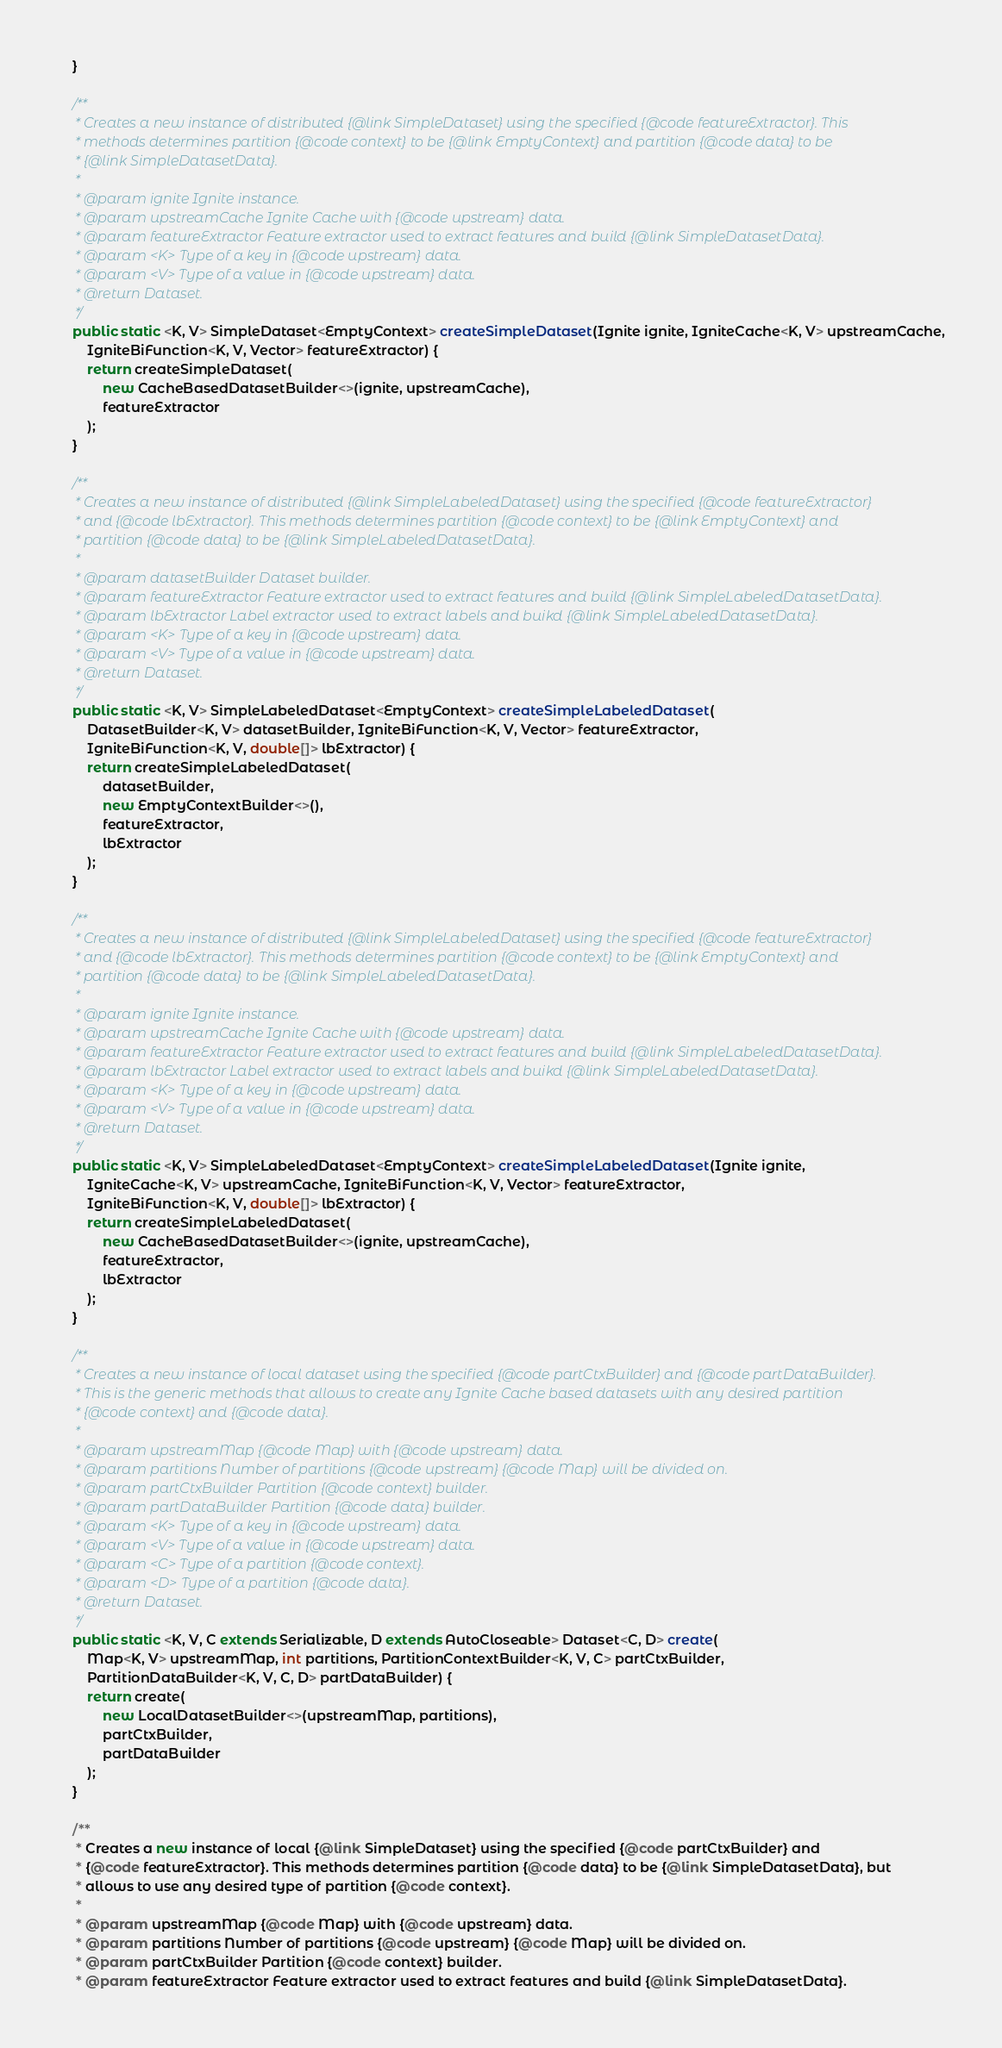<code> <loc_0><loc_0><loc_500><loc_500><_Java_>    }

    /**
     * Creates a new instance of distributed {@link SimpleDataset} using the specified {@code featureExtractor}. This
     * methods determines partition {@code context} to be {@link EmptyContext} and partition {@code data} to be
     * {@link SimpleDatasetData}.
     *
     * @param ignite Ignite instance.
     * @param upstreamCache Ignite Cache with {@code upstream} data.
     * @param featureExtractor Feature extractor used to extract features and build {@link SimpleDatasetData}.
     * @param <K> Type of a key in {@code upstream} data.
     * @param <V> Type of a value in {@code upstream} data.
     * @return Dataset.
     */
    public static <K, V> SimpleDataset<EmptyContext> createSimpleDataset(Ignite ignite, IgniteCache<K, V> upstreamCache,
        IgniteBiFunction<K, V, Vector> featureExtractor) {
        return createSimpleDataset(
            new CacheBasedDatasetBuilder<>(ignite, upstreamCache),
            featureExtractor
        );
    }

    /**
     * Creates a new instance of distributed {@link SimpleLabeledDataset} using the specified {@code featureExtractor}
     * and {@code lbExtractor}. This methods determines partition {@code context} to be {@link EmptyContext} and
     * partition {@code data} to be {@link SimpleLabeledDatasetData}.
     *
     * @param datasetBuilder Dataset builder.
     * @param featureExtractor Feature extractor used to extract features and build {@link SimpleLabeledDatasetData}.
     * @param lbExtractor Label extractor used to extract labels and buikd {@link SimpleLabeledDatasetData}.
     * @param <K> Type of a key in {@code upstream} data.
     * @param <V> Type of a value in {@code upstream} data.
     * @return Dataset.
     */
    public static <K, V> SimpleLabeledDataset<EmptyContext> createSimpleLabeledDataset(
        DatasetBuilder<K, V> datasetBuilder, IgniteBiFunction<K, V, Vector> featureExtractor,
        IgniteBiFunction<K, V, double[]> lbExtractor) {
        return createSimpleLabeledDataset(
            datasetBuilder,
            new EmptyContextBuilder<>(),
            featureExtractor,
            lbExtractor
        );
    }

    /**
     * Creates a new instance of distributed {@link SimpleLabeledDataset} using the specified {@code featureExtractor}
     * and {@code lbExtractor}. This methods determines partition {@code context} to be {@link EmptyContext} and
     * partition {@code data} to be {@link SimpleLabeledDatasetData}.
     *
     * @param ignite Ignite instance.
     * @param upstreamCache Ignite Cache with {@code upstream} data.
     * @param featureExtractor Feature extractor used to extract features and build {@link SimpleLabeledDatasetData}.
     * @param lbExtractor Label extractor used to extract labels and buikd {@link SimpleLabeledDatasetData}.
     * @param <K> Type of a key in {@code upstream} data.
     * @param <V> Type of a value in {@code upstream} data.
     * @return Dataset.
     */
    public static <K, V> SimpleLabeledDataset<EmptyContext> createSimpleLabeledDataset(Ignite ignite,
        IgniteCache<K, V> upstreamCache, IgniteBiFunction<K, V, Vector> featureExtractor,
        IgniteBiFunction<K, V, double[]> lbExtractor) {
        return createSimpleLabeledDataset(
            new CacheBasedDatasetBuilder<>(ignite, upstreamCache),
            featureExtractor,
            lbExtractor
        );
    }

    /**
     * Creates a new instance of local dataset using the specified {@code partCtxBuilder} and {@code partDataBuilder}.
     * This is the generic methods that allows to create any Ignite Cache based datasets with any desired partition
     * {@code context} and {@code data}.
     *
     * @param upstreamMap {@code Map} with {@code upstream} data.
     * @param partitions Number of partitions {@code upstream} {@code Map} will be divided on.
     * @param partCtxBuilder Partition {@code context} builder.
     * @param partDataBuilder Partition {@code data} builder.
     * @param <K> Type of a key in {@code upstream} data.
     * @param <V> Type of a value in {@code upstream} data.
     * @param <C> Type of a partition {@code context}.
     * @param <D> Type of a partition {@code data}.
     * @return Dataset.
     */
    public static <K, V, C extends Serializable, D extends AutoCloseable> Dataset<C, D> create(
        Map<K, V> upstreamMap, int partitions, PartitionContextBuilder<K, V, C> partCtxBuilder,
        PartitionDataBuilder<K, V, C, D> partDataBuilder) {
        return create(
            new LocalDatasetBuilder<>(upstreamMap, partitions),
            partCtxBuilder,
            partDataBuilder
        );
    }

    /**
     * Creates a new instance of local {@link SimpleDataset} using the specified {@code partCtxBuilder} and
     * {@code featureExtractor}. This methods determines partition {@code data} to be {@link SimpleDatasetData}, but
     * allows to use any desired type of partition {@code context}.
     *
     * @param upstreamMap {@code Map} with {@code upstream} data.
     * @param partitions Number of partitions {@code upstream} {@code Map} will be divided on.
     * @param partCtxBuilder Partition {@code context} builder.
     * @param featureExtractor Feature extractor used to extract features and build {@link SimpleDatasetData}.</code> 